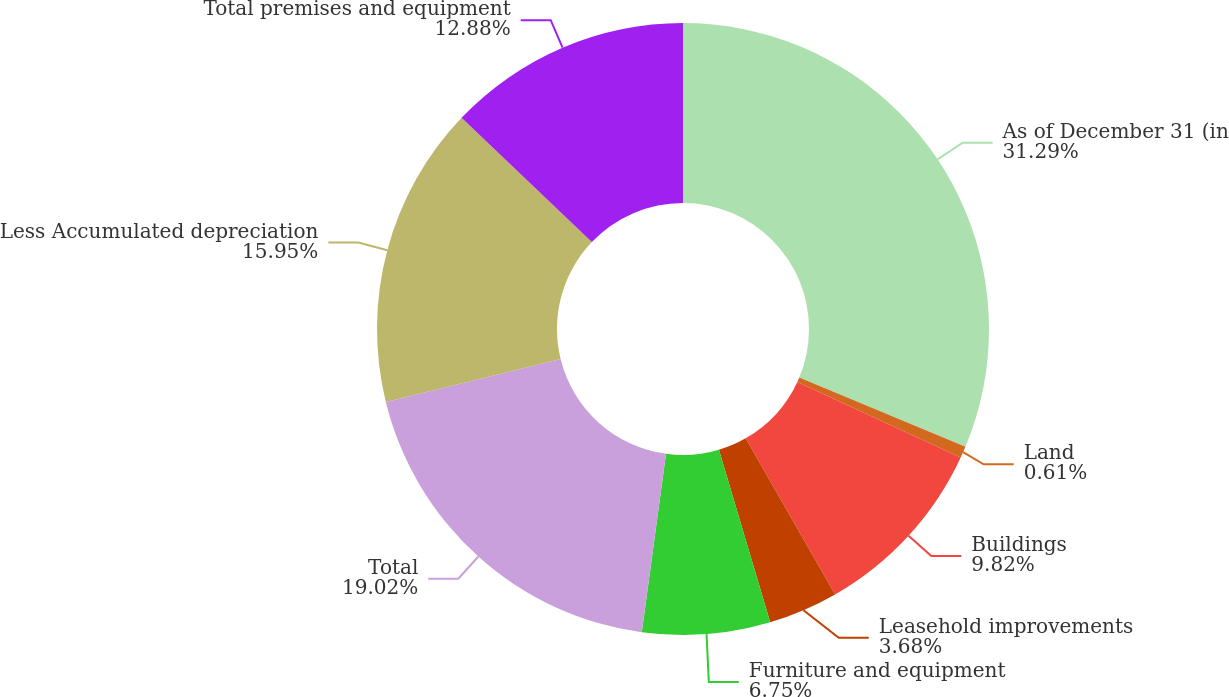Convert chart. <chart><loc_0><loc_0><loc_500><loc_500><pie_chart><fcel>As of December 31 (in<fcel>Land<fcel>Buildings<fcel>Leasehold improvements<fcel>Furniture and equipment<fcel>Total<fcel>Less Accumulated depreciation<fcel>Total premises and equipment<nl><fcel>31.29%<fcel>0.61%<fcel>9.82%<fcel>3.68%<fcel>6.75%<fcel>19.02%<fcel>15.95%<fcel>12.88%<nl></chart> 